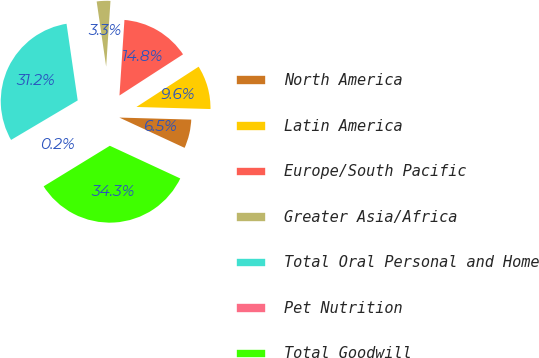Convert chart to OTSL. <chart><loc_0><loc_0><loc_500><loc_500><pie_chart><fcel>North America<fcel>Latin America<fcel>Europe/South Pacific<fcel>Greater Asia/Africa<fcel>Total Oral Personal and Home<fcel>Pet Nutrition<fcel>Total Goodwill<nl><fcel>6.47%<fcel>9.59%<fcel>14.81%<fcel>3.35%<fcel>31.22%<fcel>0.23%<fcel>34.34%<nl></chart> 